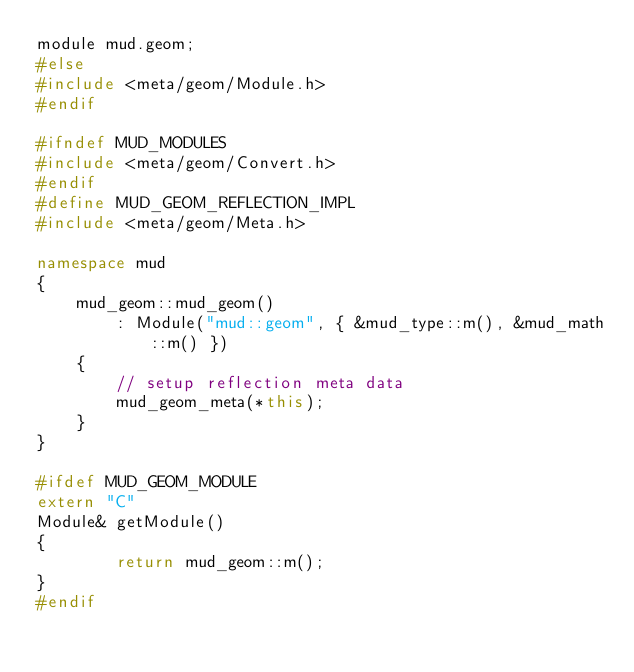Convert code to text. <code><loc_0><loc_0><loc_500><loc_500><_C++_>module mud.geom;
#else
#include <meta/geom/Module.h>
#endif

#ifndef MUD_MODULES
#include <meta/geom/Convert.h>
#endif
#define MUD_GEOM_REFLECTION_IMPL
#include <meta/geom/Meta.h>

namespace mud
{
	mud_geom::mud_geom()
		: Module("mud::geom", { &mud_type::m(), &mud_math::m() })
	{
		// setup reflection meta data
		mud_geom_meta(*this);
	}
}

#ifdef MUD_GEOM_MODULE
extern "C"
Module& getModule()
{
		return mud_geom::m();
}
#endif
</code> 